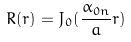<formula> <loc_0><loc_0><loc_500><loc_500>R ( r ) = J _ { 0 } ( \frac { \alpha _ { 0 n } } { a } r )</formula> 